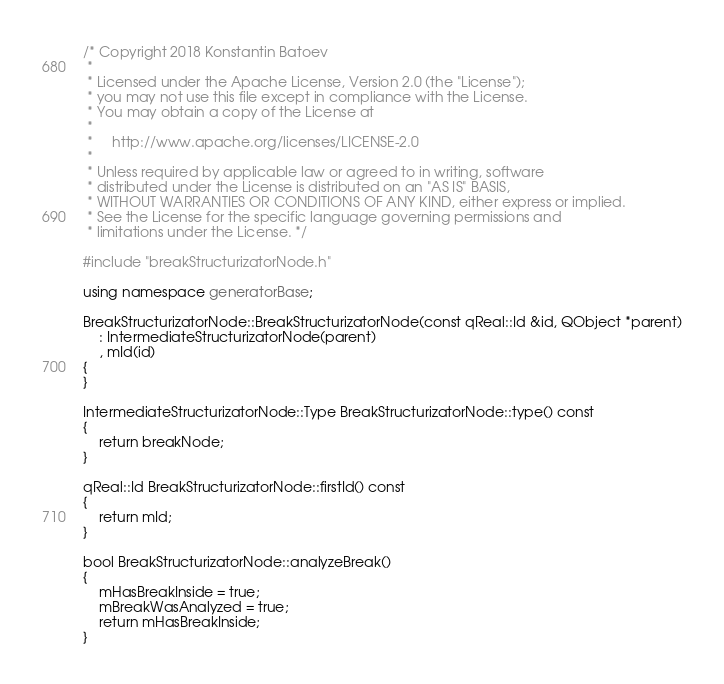<code> <loc_0><loc_0><loc_500><loc_500><_C++_>/* Copyright 2018 Konstantin Batoev
 *
 * Licensed under the Apache License, Version 2.0 (the "License");
 * you may not use this file except in compliance with the License.
 * You may obtain a copy of the License at
 *
 *     http://www.apache.org/licenses/LICENSE-2.0
 *
 * Unless required by applicable law or agreed to in writing, software
 * distributed under the License is distributed on an "AS IS" BASIS,
 * WITHOUT WARRANTIES OR CONDITIONS OF ANY KIND, either express or implied.
 * See the License for the specific language governing permissions and
 * limitations under the License. */

#include "breakStructurizatorNode.h"

using namespace generatorBase;

BreakStructurizatorNode::BreakStructurizatorNode(const qReal::Id &id, QObject *parent)
	: IntermediateStructurizatorNode(parent)
	, mId(id)
{
}

IntermediateStructurizatorNode::Type BreakStructurizatorNode::type() const
{
	return breakNode;
}

qReal::Id BreakStructurizatorNode::firstId() const
{
	return mId;
}

bool BreakStructurizatorNode::analyzeBreak()
{
	mHasBreakInside = true;
	mBreakWasAnalyzed = true;
	return mHasBreakInside;
}
</code> 